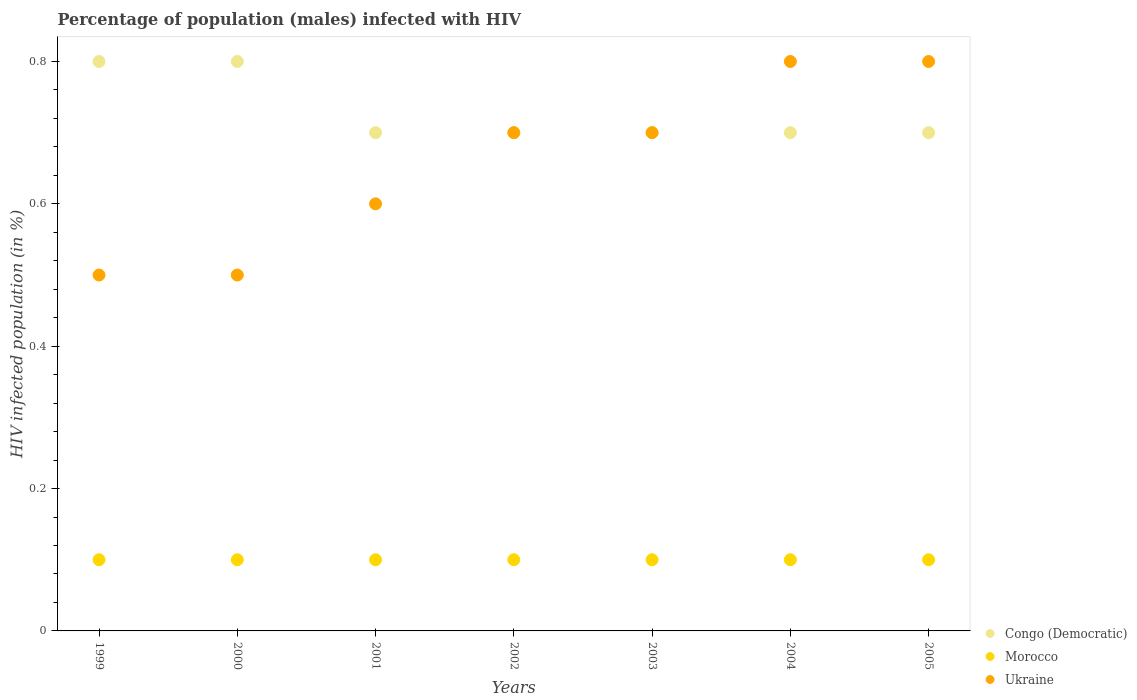Across all years, what is the maximum percentage of HIV infected male population in Ukraine?
Give a very brief answer. 0.8. Across all years, what is the minimum percentage of HIV infected male population in Morocco?
Your answer should be very brief. 0.1. In which year was the percentage of HIV infected male population in Ukraine maximum?
Give a very brief answer. 2004. What is the difference between the percentage of HIV infected male population in Congo (Democratic) in 2004 and that in 2005?
Offer a very short reply. 0. What is the difference between the percentage of HIV infected male population in Morocco in 2002 and the percentage of HIV infected male population in Congo (Democratic) in 2005?
Your response must be concise. -0.6. What is the average percentage of HIV infected male population in Congo (Democratic) per year?
Your answer should be very brief. 0.73. In the year 2003, what is the difference between the percentage of HIV infected male population in Morocco and percentage of HIV infected male population in Ukraine?
Provide a succinct answer. -0.6. In how many years, is the percentage of HIV infected male population in Morocco greater than 0.6000000000000001 %?
Offer a very short reply. 0. What is the ratio of the percentage of HIV infected male population in Congo (Democratic) in 1999 to that in 2005?
Offer a terse response. 1.14. What is the difference between the highest and the second highest percentage of HIV infected male population in Morocco?
Your response must be concise. 0. What is the difference between the highest and the lowest percentage of HIV infected male population in Congo (Democratic)?
Offer a very short reply. 0.1. In how many years, is the percentage of HIV infected male population in Ukraine greater than the average percentage of HIV infected male population in Ukraine taken over all years?
Make the answer very short. 4. Is the sum of the percentage of HIV infected male population in Morocco in 2000 and 2004 greater than the maximum percentage of HIV infected male population in Congo (Democratic) across all years?
Your answer should be compact. No. Is it the case that in every year, the sum of the percentage of HIV infected male population in Ukraine and percentage of HIV infected male population in Morocco  is greater than the percentage of HIV infected male population in Congo (Democratic)?
Provide a short and direct response. No. Does the percentage of HIV infected male population in Congo (Democratic) monotonically increase over the years?
Ensure brevity in your answer.  No. Is the percentage of HIV infected male population in Ukraine strictly less than the percentage of HIV infected male population in Congo (Democratic) over the years?
Offer a terse response. No. Does the graph contain any zero values?
Keep it short and to the point. No. Does the graph contain grids?
Your answer should be compact. No. What is the title of the graph?
Provide a succinct answer. Percentage of population (males) infected with HIV. Does "Low & middle income" appear as one of the legend labels in the graph?
Provide a succinct answer. No. What is the label or title of the Y-axis?
Your answer should be very brief. HIV infected population (in %). What is the HIV infected population (in %) of Morocco in 1999?
Provide a succinct answer. 0.1. What is the HIV infected population (in %) of Congo (Democratic) in 2000?
Your answer should be compact. 0.8. What is the HIV infected population (in %) of Morocco in 2000?
Your response must be concise. 0.1. What is the HIV infected population (in %) in Ukraine in 2000?
Give a very brief answer. 0.5. What is the HIV infected population (in %) in Congo (Democratic) in 2001?
Provide a short and direct response. 0.7. What is the HIV infected population (in %) in Congo (Democratic) in 2003?
Give a very brief answer. 0.7. What is the HIV infected population (in %) of Morocco in 2003?
Give a very brief answer. 0.1. What is the HIV infected population (in %) in Ukraine in 2003?
Provide a short and direct response. 0.7. What is the HIV infected population (in %) of Congo (Democratic) in 2004?
Your answer should be compact. 0.7. Across all years, what is the minimum HIV infected population (in %) of Congo (Democratic)?
Your response must be concise. 0.7. Across all years, what is the minimum HIV infected population (in %) of Morocco?
Your answer should be very brief. 0.1. What is the total HIV infected population (in %) of Congo (Democratic) in the graph?
Provide a short and direct response. 5.1. What is the total HIV infected population (in %) of Ukraine in the graph?
Keep it short and to the point. 4.6. What is the difference between the HIV infected population (in %) in Morocco in 1999 and that in 2000?
Ensure brevity in your answer.  0. What is the difference between the HIV infected population (in %) in Ukraine in 1999 and that in 2000?
Provide a short and direct response. 0. What is the difference between the HIV infected population (in %) of Morocco in 1999 and that in 2001?
Your answer should be very brief. 0. What is the difference between the HIV infected population (in %) of Morocco in 1999 and that in 2002?
Offer a terse response. 0. What is the difference between the HIV infected population (in %) of Ukraine in 1999 and that in 2002?
Offer a terse response. -0.2. What is the difference between the HIV infected population (in %) in Congo (Democratic) in 1999 and that in 2003?
Provide a short and direct response. 0.1. What is the difference between the HIV infected population (in %) of Ukraine in 1999 and that in 2003?
Provide a succinct answer. -0.2. What is the difference between the HIV infected population (in %) of Ukraine in 1999 and that in 2004?
Provide a short and direct response. -0.3. What is the difference between the HIV infected population (in %) of Ukraine in 2000 and that in 2001?
Your response must be concise. -0.1. What is the difference between the HIV infected population (in %) of Morocco in 2000 and that in 2002?
Keep it short and to the point. 0. What is the difference between the HIV infected population (in %) of Morocco in 2000 and that in 2004?
Your answer should be very brief. 0. What is the difference between the HIV infected population (in %) of Ukraine in 2000 and that in 2004?
Provide a short and direct response. -0.3. What is the difference between the HIV infected population (in %) of Congo (Democratic) in 2000 and that in 2005?
Provide a succinct answer. 0.1. What is the difference between the HIV infected population (in %) of Morocco in 2001 and that in 2002?
Give a very brief answer. 0. What is the difference between the HIV infected population (in %) of Ukraine in 2001 and that in 2002?
Give a very brief answer. -0.1. What is the difference between the HIV infected population (in %) of Morocco in 2001 and that in 2003?
Give a very brief answer. 0. What is the difference between the HIV infected population (in %) in Congo (Democratic) in 2001 and that in 2004?
Provide a succinct answer. 0. What is the difference between the HIV infected population (in %) of Ukraine in 2001 and that in 2004?
Ensure brevity in your answer.  -0.2. What is the difference between the HIV infected population (in %) in Congo (Democratic) in 2001 and that in 2005?
Your answer should be very brief. 0. What is the difference between the HIV infected population (in %) in Morocco in 2001 and that in 2005?
Keep it short and to the point. 0. What is the difference between the HIV infected population (in %) in Morocco in 2002 and that in 2003?
Ensure brevity in your answer.  0. What is the difference between the HIV infected population (in %) of Ukraine in 2002 and that in 2003?
Offer a very short reply. 0. What is the difference between the HIV infected population (in %) of Congo (Democratic) in 2002 and that in 2004?
Your answer should be compact. 0. What is the difference between the HIV infected population (in %) in Morocco in 2002 and that in 2004?
Provide a short and direct response. 0. What is the difference between the HIV infected population (in %) in Ukraine in 2002 and that in 2004?
Ensure brevity in your answer.  -0.1. What is the difference between the HIV infected population (in %) in Congo (Democratic) in 2002 and that in 2005?
Give a very brief answer. 0. What is the difference between the HIV infected population (in %) of Morocco in 2002 and that in 2005?
Make the answer very short. 0. What is the difference between the HIV infected population (in %) of Ukraine in 2002 and that in 2005?
Your response must be concise. -0.1. What is the difference between the HIV infected population (in %) in Ukraine in 2003 and that in 2004?
Your response must be concise. -0.1. What is the difference between the HIV infected population (in %) of Congo (Democratic) in 2003 and that in 2005?
Offer a terse response. 0. What is the difference between the HIV infected population (in %) in Morocco in 2003 and that in 2005?
Provide a succinct answer. 0. What is the difference between the HIV infected population (in %) in Congo (Democratic) in 2004 and that in 2005?
Keep it short and to the point. 0. What is the difference between the HIV infected population (in %) of Morocco in 2004 and that in 2005?
Your answer should be very brief. 0. What is the difference between the HIV infected population (in %) of Congo (Democratic) in 1999 and the HIV infected population (in %) of Ukraine in 2000?
Ensure brevity in your answer.  0.3. What is the difference between the HIV infected population (in %) in Congo (Democratic) in 1999 and the HIV infected population (in %) in Ukraine in 2001?
Keep it short and to the point. 0.2. What is the difference between the HIV infected population (in %) in Morocco in 1999 and the HIV infected population (in %) in Ukraine in 2001?
Provide a short and direct response. -0.5. What is the difference between the HIV infected population (in %) of Congo (Democratic) in 1999 and the HIV infected population (in %) of Morocco in 2002?
Provide a short and direct response. 0.7. What is the difference between the HIV infected population (in %) in Congo (Democratic) in 1999 and the HIV infected population (in %) in Ukraine in 2002?
Offer a terse response. 0.1. What is the difference between the HIV infected population (in %) of Morocco in 1999 and the HIV infected population (in %) of Ukraine in 2002?
Ensure brevity in your answer.  -0.6. What is the difference between the HIV infected population (in %) of Congo (Democratic) in 1999 and the HIV infected population (in %) of Morocco in 2003?
Provide a succinct answer. 0.7. What is the difference between the HIV infected population (in %) in Morocco in 1999 and the HIV infected population (in %) in Ukraine in 2004?
Make the answer very short. -0.7. What is the difference between the HIV infected population (in %) of Congo (Democratic) in 1999 and the HIV infected population (in %) of Ukraine in 2005?
Make the answer very short. 0. What is the difference between the HIV infected population (in %) in Morocco in 1999 and the HIV infected population (in %) in Ukraine in 2005?
Ensure brevity in your answer.  -0.7. What is the difference between the HIV infected population (in %) in Congo (Democratic) in 2000 and the HIV infected population (in %) in Morocco in 2002?
Your answer should be very brief. 0.7. What is the difference between the HIV infected population (in %) of Congo (Democratic) in 2000 and the HIV infected population (in %) of Morocco in 2003?
Provide a succinct answer. 0.7. What is the difference between the HIV infected population (in %) of Morocco in 2000 and the HIV infected population (in %) of Ukraine in 2003?
Your response must be concise. -0.6. What is the difference between the HIV infected population (in %) of Congo (Democratic) in 2000 and the HIV infected population (in %) of Morocco in 2004?
Your answer should be very brief. 0.7. What is the difference between the HIV infected population (in %) in Congo (Democratic) in 2000 and the HIV infected population (in %) in Ukraine in 2004?
Ensure brevity in your answer.  0. What is the difference between the HIV infected population (in %) of Morocco in 2000 and the HIV infected population (in %) of Ukraine in 2004?
Your answer should be very brief. -0.7. What is the difference between the HIV infected population (in %) in Congo (Democratic) in 2000 and the HIV infected population (in %) in Morocco in 2005?
Provide a short and direct response. 0.7. What is the difference between the HIV infected population (in %) in Morocco in 2000 and the HIV infected population (in %) in Ukraine in 2005?
Provide a succinct answer. -0.7. What is the difference between the HIV infected population (in %) in Congo (Democratic) in 2001 and the HIV infected population (in %) in Ukraine in 2002?
Offer a terse response. 0. What is the difference between the HIV infected population (in %) in Congo (Democratic) in 2001 and the HIV infected population (in %) in Morocco in 2003?
Give a very brief answer. 0.6. What is the difference between the HIV infected population (in %) of Congo (Democratic) in 2001 and the HIV infected population (in %) of Ukraine in 2003?
Give a very brief answer. 0. What is the difference between the HIV infected population (in %) in Morocco in 2001 and the HIV infected population (in %) in Ukraine in 2003?
Your response must be concise. -0.6. What is the difference between the HIV infected population (in %) in Congo (Democratic) in 2001 and the HIV infected population (in %) in Morocco in 2004?
Provide a succinct answer. 0.6. What is the difference between the HIV infected population (in %) of Congo (Democratic) in 2001 and the HIV infected population (in %) of Ukraine in 2004?
Your response must be concise. -0.1. What is the difference between the HIV infected population (in %) of Morocco in 2001 and the HIV infected population (in %) of Ukraine in 2004?
Keep it short and to the point. -0.7. What is the difference between the HIV infected population (in %) in Morocco in 2001 and the HIV infected population (in %) in Ukraine in 2005?
Your answer should be very brief. -0.7. What is the difference between the HIV infected population (in %) of Morocco in 2002 and the HIV infected population (in %) of Ukraine in 2003?
Offer a terse response. -0.6. What is the difference between the HIV infected population (in %) in Congo (Democratic) in 2002 and the HIV infected population (in %) in Morocco in 2004?
Your answer should be compact. 0.6. What is the difference between the HIV infected population (in %) of Morocco in 2002 and the HIV infected population (in %) of Ukraine in 2004?
Offer a terse response. -0.7. What is the difference between the HIV infected population (in %) in Congo (Democratic) in 2002 and the HIV infected population (in %) in Ukraine in 2005?
Offer a terse response. -0.1. What is the difference between the HIV infected population (in %) in Congo (Democratic) in 2003 and the HIV infected population (in %) in Morocco in 2004?
Offer a very short reply. 0.6. What is the difference between the HIV infected population (in %) of Congo (Democratic) in 2003 and the HIV infected population (in %) of Ukraine in 2004?
Give a very brief answer. -0.1. What is the difference between the HIV infected population (in %) of Morocco in 2003 and the HIV infected population (in %) of Ukraine in 2004?
Provide a short and direct response. -0.7. What is the difference between the HIV infected population (in %) of Congo (Democratic) in 2003 and the HIV infected population (in %) of Morocco in 2005?
Offer a terse response. 0.6. What is the difference between the HIV infected population (in %) in Congo (Democratic) in 2004 and the HIV infected population (in %) in Morocco in 2005?
Ensure brevity in your answer.  0.6. What is the difference between the HIV infected population (in %) in Congo (Democratic) in 2004 and the HIV infected population (in %) in Ukraine in 2005?
Ensure brevity in your answer.  -0.1. What is the difference between the HIV infected population (in %) in Morocco in 2004 and the HIV infected population (in %) in Ukraine in 2005?
Your response must be concise. -0.7. What is the average HIV infected population (in %) in Congo (Democratic) per year?
Make the answer very short. 0.73. What is the average HIV infected population (in %) of Morocco per year?
Give a very brief answer. 0.1. What is the average HIV infected population (in %) of Ukraine per year?
Keep it short and to the point. 0.66. In the year 1999, what is the difference between the HIV infected population (in %) of Congo (Democratic) and HIV infected population (in %) of Morocco?
Offer a terse response. 0.7. In the year 1999, what is the difference between the HIV infected population (in %) in Congo (Democratic) and HIV infected population (in %) in Ukraine?
Keep it short and to the point. 0.3. In the year 1999, what is the difference between the HIV infected population (in %) of Morocco and HIV infected population (in %) of Ukraine?
Offer a terse response. -0.4. In the year 2000, what is the difference between the HIV infected population (in %) in Congo (Democratic) and HIV infected population (in %) in Morocco?
Your response must be concise. 0.7. In the year 2000, what is the difference between the HIV infected population (in %) in Morocco and HIV infected population (in %) in Ukraine?
Your response must be concise. -0.4. In the year 2001, what is the difference between the HIV infected population (in %) of Congo (Democratic) and HIV infected population (in %) of Morocco?
Give a very brief answer. 0.6. In the year 2001, what is the difference between the HIV infected population (in %) of Congo (Democratic) and HIV infected population (in %) of Ukraine?
Provide a short and direct response. 0.1. In the year 2002, what is the difference between the HIV infected population (in %) in Congo (Democratic) and HIV infected population (in %) in Ukraine?
Provide a succinct answer. 0. In the year 2003, what is the difference between the HIV infected population (in %) in Congo (Democratic) and HIV infected population (in %) in Morocco?
Offer a very short reply. 0.6. In the year 2004, what is the difference between the HIV infected population (in %) in Congo (Democratic) and HIV infected population (in %) in Ukraine?
Provide a short and direct response. -0.1. In the year 2004, what is the difference between the HIV infected population (in %) of Morocco and HIV infected population (in %) of Ukraine?
Your answer should be very brief. -0.7. In the year 2005, what is the difference between the HIV infected population (in %) in Congo (Democratic) and HIV infected population (in %) in Morocco?
Offer a terse response. 0.6. In the year 2005, what is the difference between the HIV infected population (in %) of Congo (Democratic) and HIV infected population (in %) of Ukraine?
Offer a terse response. -0.1. In the year 2005, what is the difference between the HIV infected population (in %) of Morocco and HIV infected population (in %) of Ukraine?
Your response must be concise. -0.7. What is the ratio of the HIV infected population (in %) in Morocco in 1999 to that in 2000?
Offer a very short reply. 1. What is the ratio of the HIV infected population (in %) of Ukraine in 1999 to that in 2000?
Your response must be concise. 1. What is the ratio of the HIV infected population (in %) of Congo (Democratic) in 1999 to that in 2001?
Offer a terse response. 1.14. What is the ratio of the HIV infected population (in %) of Ukraine in 1999 to that in 2001?
Give a very brief answer. 0.83. What is the ratio of the HIV infected population (in %) of Morocco in 1999 to that in 2002?
Provide a succinct answer. 1. What is the ratio of the HIV infected population (in %) in Congo (Democratic) in 1999 to that in 2003?
Provide a short and direct response. 1.14. What is the ratio of the HIV infected population (in %) of Ukraine in 1999 to that in 2003?
Keep it short and to the point. 0.71. What is the ratio of the HIV infected population (in %) of Congo (Democratic) in 1999 to that in 2004?
Keep it short and to the point. 1.14. What is the ratio of the HIV infected population (in %) of Morocco in 1999 to that in 2004?
Make the answer very short. 1. What is the ratio of the HIV infected population (in %) of Congo (Democratic) in 1999 to that in 2005?
Give a very brief answer. 1.14. What is the ratio of the HIV infected population (in %) in Morocco in 1999 to that in 2005?
Keep it short and to the point. 1. What is the ratio of the HIV infected population (in %) of Congo (Democratic) in 2000 to that in 2001?
Your response must be concise. 1.14. What is the ratio of the HIV infected population (in %) of Ukraine in 2000 to that in 2001?
Provide a short and direct response. 0.83. What is the ratio of the HIV infected population (in %) of Congo (Democratic) in 2000 to that in 2002?
Make the answer very short. 1.14. What is the ratio of the HIV infected population (in %) in Morocco in 2000 to that in 2002?
Offer a very short reply. 1. What is the ratio of the HIV infected population (in %) in Ukraine in 2000 to that in 2002?
Give a very brief answer. 0.71. What is the ratio of the HIV infected population (in %) in Morocco in 2000 to that in 2003?
Keep it short and to the point. 1. What is the ratio of the HIV infected population (in %) in Ukraine in 2000 to that in 2003?
Ensure brevity in your answer.  0.71. What is the ratio of the HIV infected population (in %) of Morocco in 2000 to that in 2004?
Your answer should be compact. 1. What is the ratio of the HIV infected population (in %) of Congo (Democratic) in 2000 to that in 2005?
Make the answer very short. 1.14. What is the ratio of the HIV infected population (in %) of Morocco in 2000 to that in 2005?
Your response must be concise. 1. What is the ratio of the HIV infected population (in %) in Congo (Democratic) in 2001 to that in 2002?
Keep it short and to the point. 1. What is the ratio of the HIV infected population (in %) in Morocco in 2001 to that in 2002?
Your response must be concise. 1. What is the ratio of the HIV infected population (in %) in Congo (Democratic) in 2001 to that in 2004?
Provide a succinct answer. 1. What is the ratio of the HIV infected population (in %) of Morocco in 2001 to that in 2004?
Give a very brief answer. 1. What is the ratio of the HIV infected population (in %) of Congo (Democratic) in 2001 to that in 2005?
Your response must be concise. 1. What is the ratio of the HIV infected population (in %) in Ukraine in 2001 to that in 2005?
Your response must be concise. 0.75. What is the ratio of the HIV infected population (in %) of Congo (Democratic) in 2002 to that in 2003?
Your response must be concise. 1. What is the ratio of the HIV infected population (in %) in Morocco in 2002 to that in 2003?
Offer a terse response. 1. What is the ratio of the HIV infected population (in %) of Ukraine in 2002 to that in 2003?
Your response must be concise. 1. What is the ratio of the HIV infected population (in %) in Ukraine in 2002 to that in 2004?
Ensure brevity in your answer.  0.88. What is the ratio of the HIV infected population (in %) in Congo (Democratic) in 2002 to that in 2005?
Keep it short and to the point. 1. What is the ratio of the HIV infected population (in %) of Morocco in 2002 to that in 2005?
Provide a succinct answer. 1. What is the ratio of the HIV infected population (in %) in Ukraine in 2003 to that in 2004?
Your answer should be very brief. 0.88. What is the ratio of the HIV infected population (in %) in Congo (Democratic) in 2004 to that in 2005?
Ensure brevity in your answer.  1. What is the difference between the highest and the second highest HIV infected population (in %) of Congo (Democratic)?
Make the answer very short. 0. What is the difference between the highest and the second highest HIV infected population (in %) of Morocco?
Make the answer very short. 0. What is the difference between the highest and the second highest HIV infected population (in %) of Ukraine?
Offer a terse response. 0. What is the difference between the highest and the lowest HIV infected population (in %) in Morocco?
Make the answer very short. 0. 